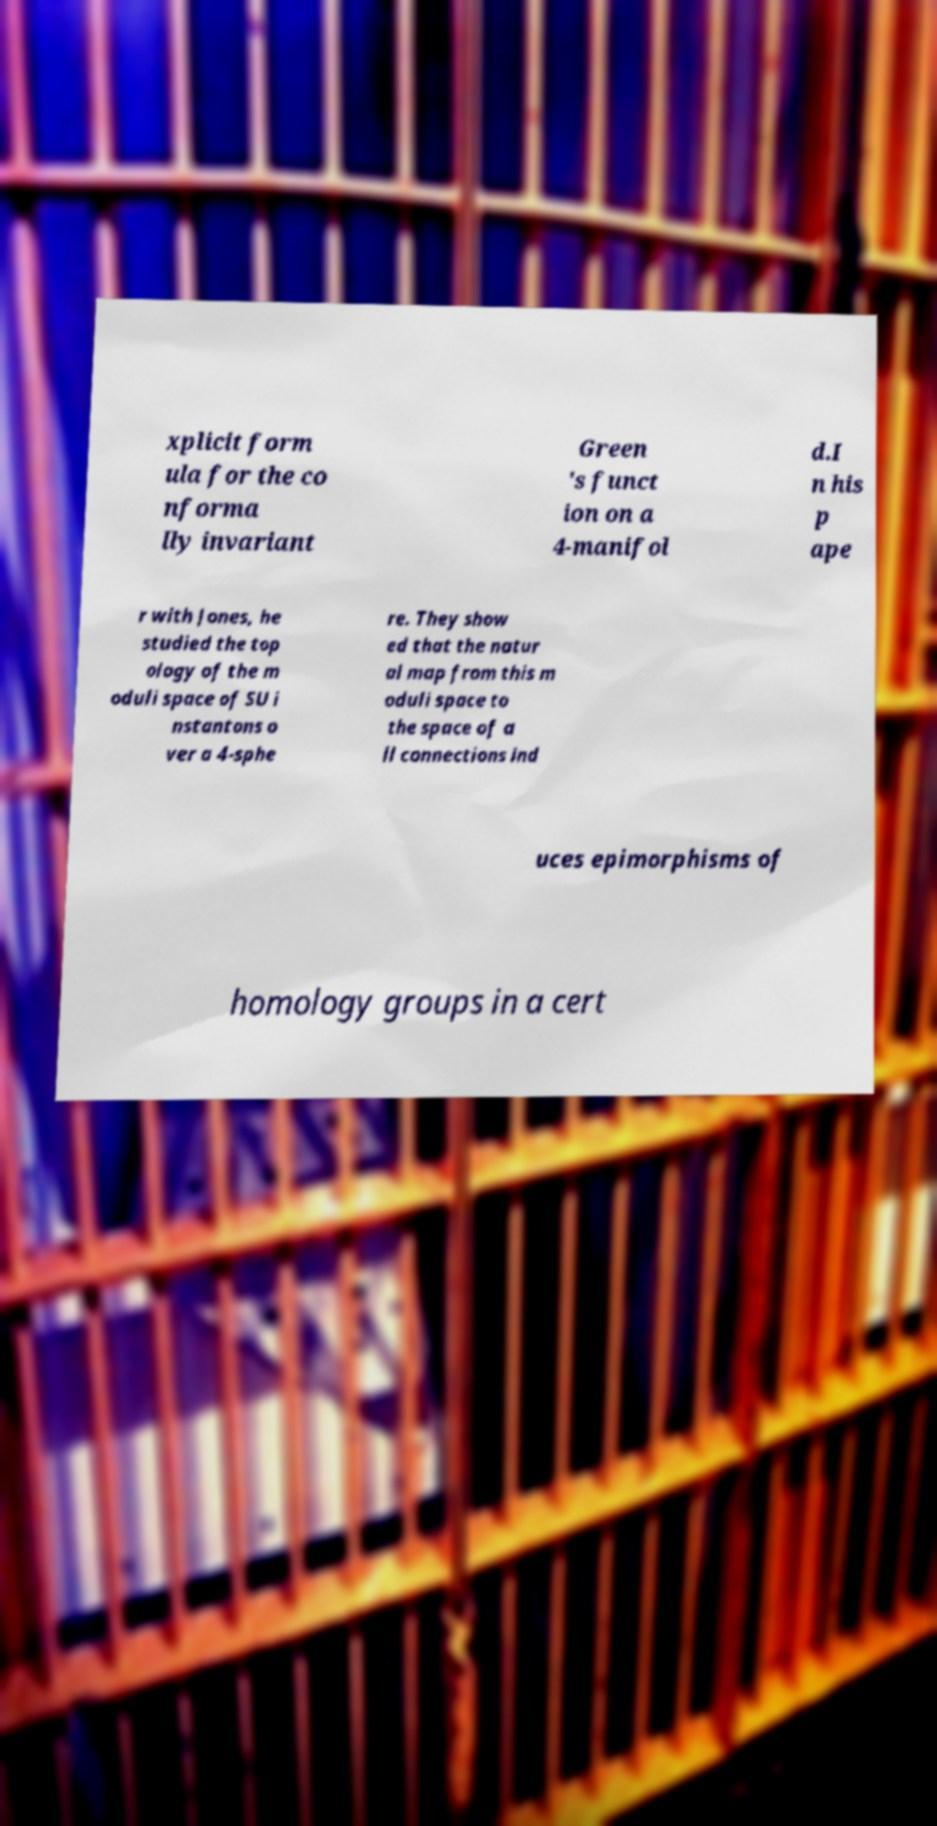Could you extract and type out the text from this image? xplicit form ula for the co nforma lly invariant Green 's funct ion on a 4-manifol d.I n his p ape r with Jones, he studied the top ology of the m oduli space of SU i nstantons o ver a 4-sphe re. They show ed that the natur al map from this m oduli space to the space of a ll connections ind uces epimorphisms of homology groups in a cert 